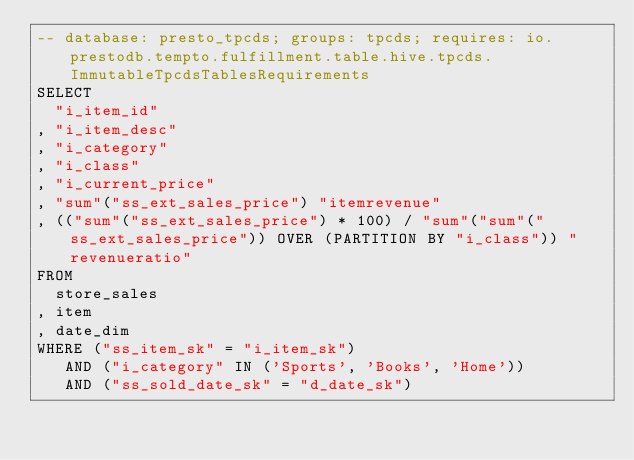<code> <loc_0><loc_0><loc_500><loc_500><_SQL_>-- database: presto_tpcds; groups: tpcds; requires: io.prestodb.tempto.fulfillment.table.hive.tpcds.ImmutableTpcdsTablesRequirements
SELECT
  "i_item_id"
, "i_item_desc"
, "i_category"
, "i_class"
, "i_current_price"
, "sum"("ss_ext_sales_price") "itemrevenue"
, (("sum"("ss_ext_sales_price") * 100) / "sum"("sum"("ss_ext_sales_price")) OVER (PARTITION BY "i_class")) "revenueratio"
FROM
  store_sales
, item
, date_dim
WHERE ("ss_item_sk" = "i_item_sk")
   AND ("i_category" IN ('Sports', 'Books', 'Home'))
   AND ("ss_sold_date_sk" = "d_date_sk")</code> 